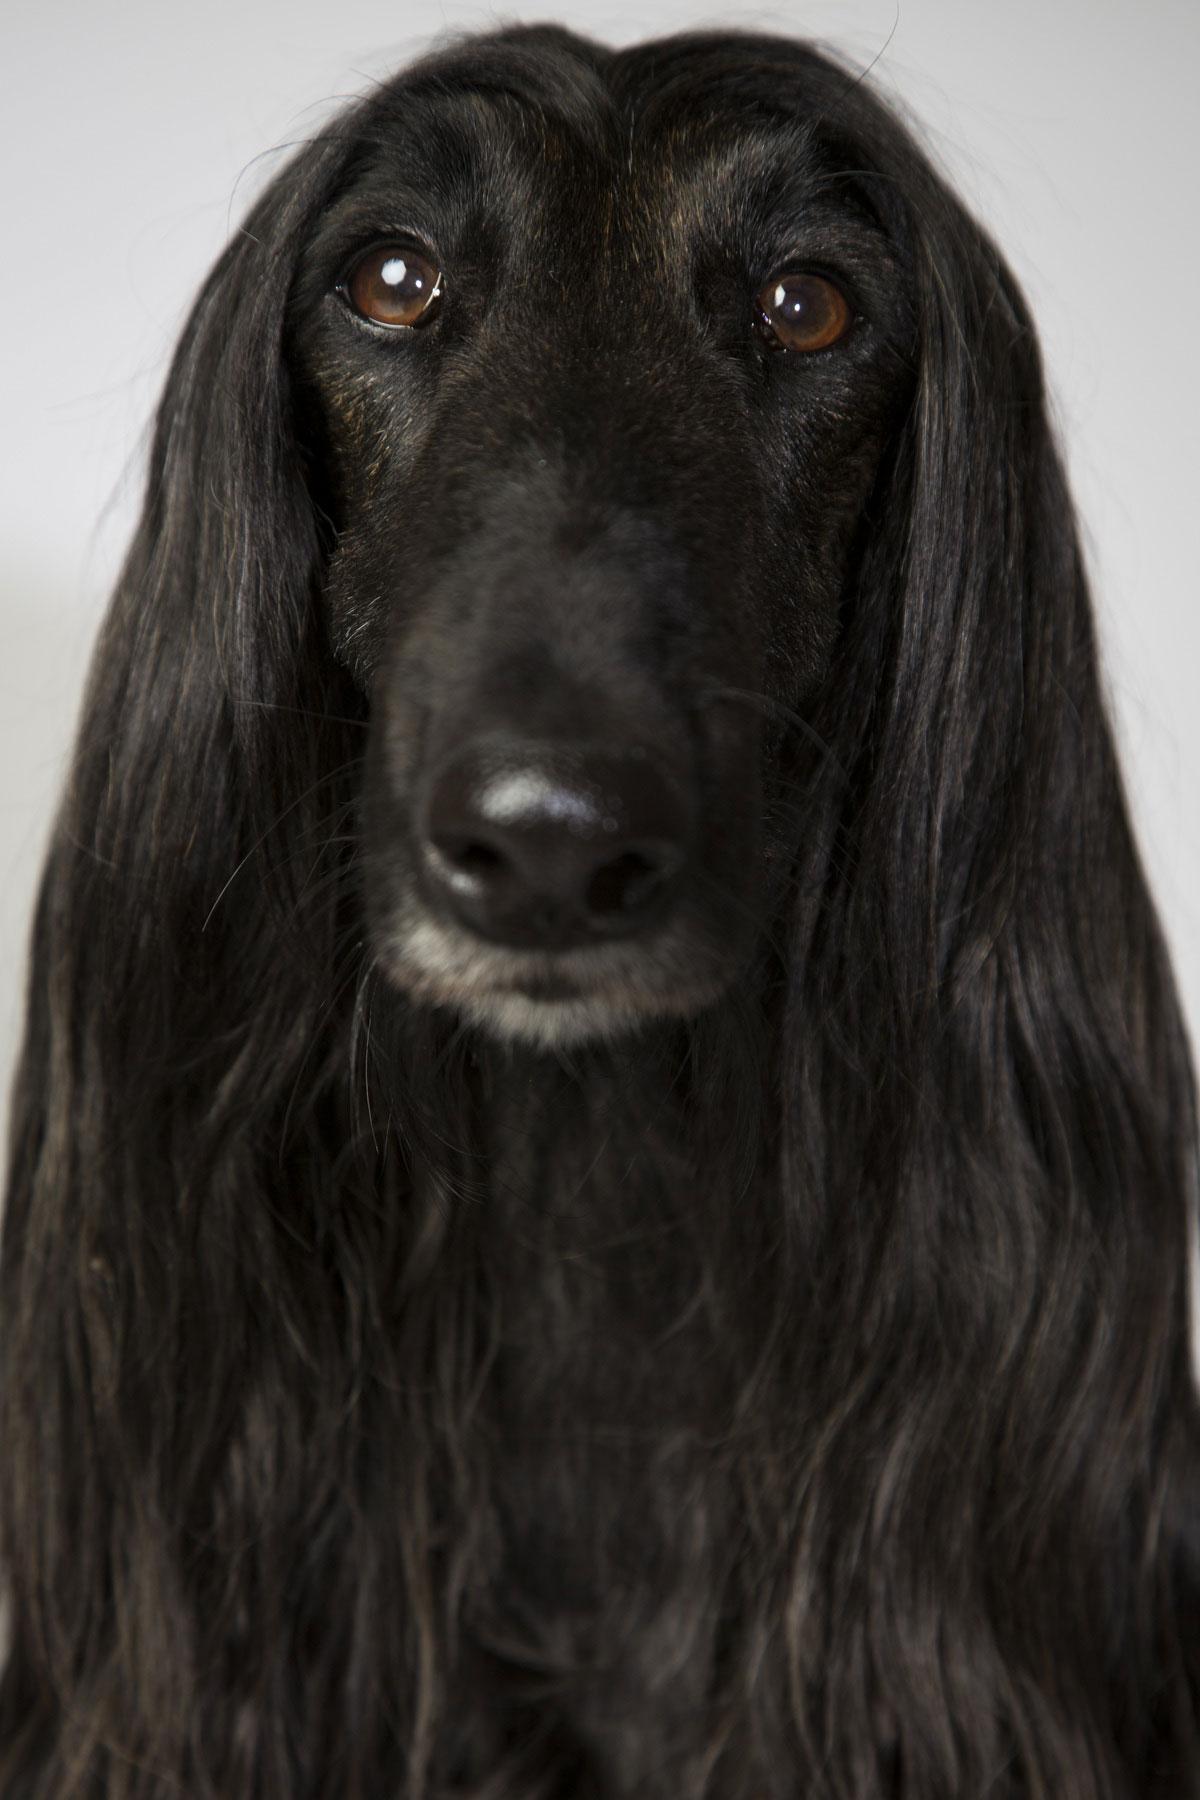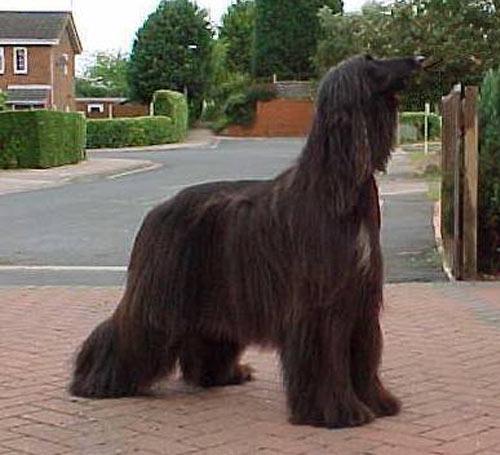The first image is the image on the left, the second image is the image on the right. For the images displayed, is the sentence "One of the images has a black dog with long hair standing up." factually correct? Answer yes or no. Yes. The first image is the image on the left, the second image is the image on the right. For the images shown, is this caption "Each image contains a black afghan hound, and the right image shows a hound standing with its body in profile." true? Answer yes or no. Yes. 